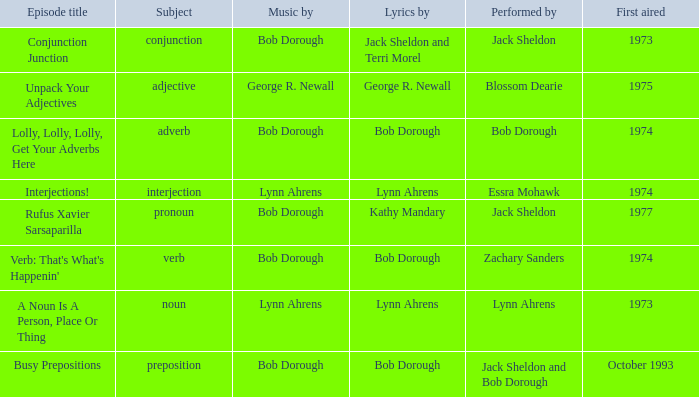When zachary sanders performs, how many initial airings are there? 1.0. 